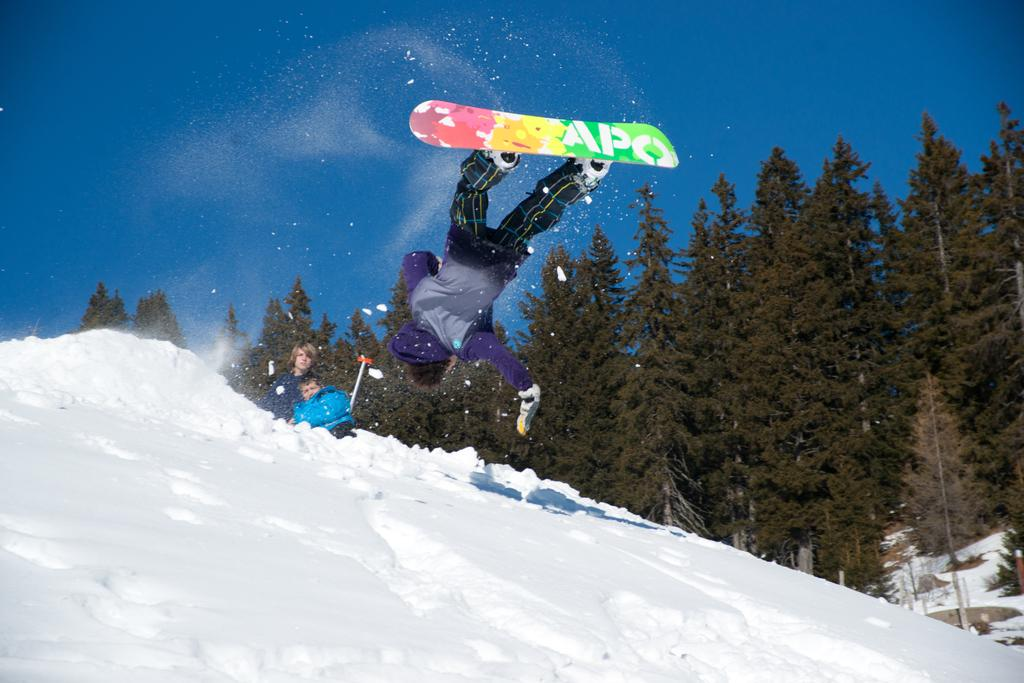What is the main subject in the foreground of the image? There is a man on a skateboard in the foreground. What is the man on the skateboard doing? The man is in the air, suggesting he is performing a trick or jump. What can be seen at the bottom of the image? There is snow at the bottom of the image. What is visible in the background of the image? There are people, trees, and the sky visible in the background. What type of route can be seen in the image? There is no route visible in the image; it features a man on a skateboard in the air, snow at the bottom, and people, trees, and the sky in the background. Can you tell me how many boats are present in the image? There are no boats present in the image. 